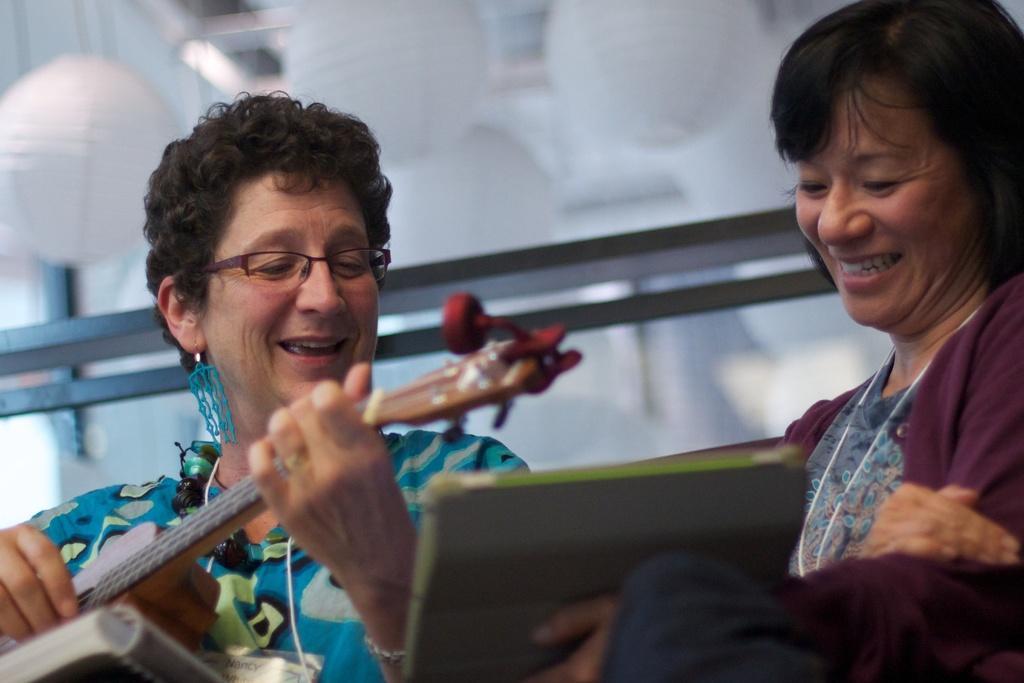Describe this image in one or two sentences. In this image there are two people. At the right side of the image there is a person is smiling and holding the book and the person at the left side of the image is smiling and playing guitar. At the top there are lights lamps. 